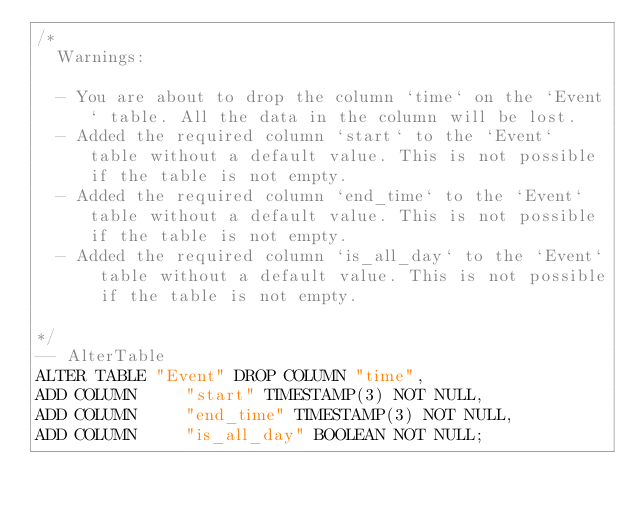<code> <loc_0><loc_0><loc_500><loc_500><_SQL_>/*
  Warnings:

  - You are about to drop the column `time` on the `Event` table. All the data in the column will be lost.
  - Added the required column `start` to the `Event` table without a default value. This is not possible if the table is not empty.
  - Added the required column `end_time` to the `Event` table without a default value. This is not possible if the table is not empty.
  - Added the required column `is_all_day` to the `Event` table without a default value. This is not possible if the table is not empty.

*/
-- AlterTable
ALTER TABLE "Event" DROP COLUMN "time",
ADD COLUMN     "start" TIMESTAMP(3) NOT NULL,
ADD COLUMN     "end_time" TIMESTAMP(3) NOT NULL,
ADD COLUMN     "is_all_day" BOOLEAN NOT NULL;
</code> 